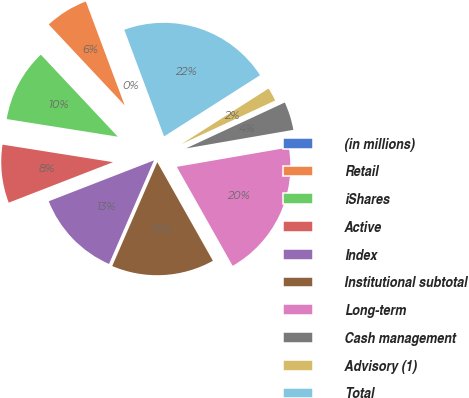<chart> <loc_0><loc_0><loc_500><loc_500><pie_chart><fcel>(in millions)<fcel>Retail<fcel>iShares<fcel>Active<fcel>Index<fcel>Institutional subtotal<fcel>Long-term<fcel>Cash management<fcel>Advisory (1)<fcel>Total<nl><fcel>0.01%<fcel>6.3%<fcel>10.5%<fcel>8.4%<fcel>12.59%<fcel>14.69%<fcel>19.55%<fcel>4.2%<fcel>2.11%<fcel>21.65%<nl></chart> 